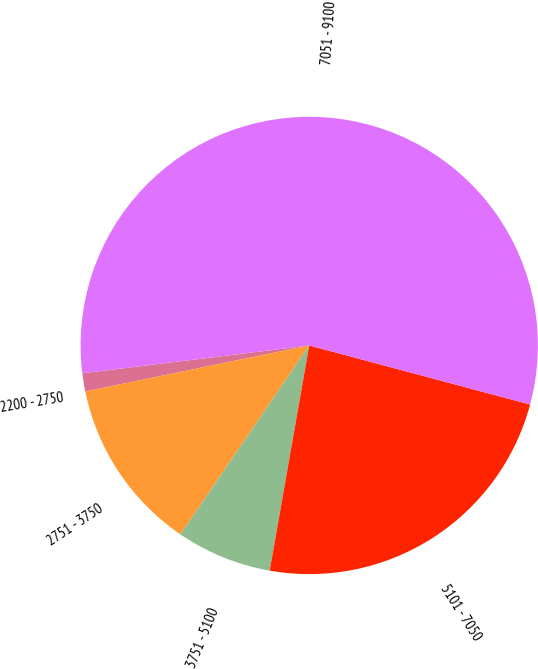Convert chart to OTSL. <chart><loc_0><loc_0><loc_500><loc_500><pie_chart><fcel>2200 - 2750<fcel>2751 - 3750<fcel>3751 - 5100<fcel>5101 - 7050<fcel>7051 - 9100<nl><fcel>1.28%<fcel>12.25%<fcel>6.76%<fcel>23.61%<fcel>56.1%<nl></chart> 